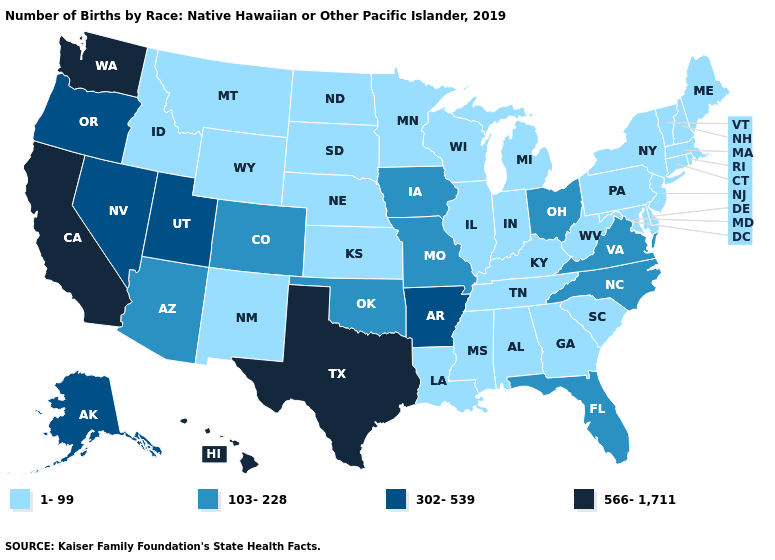Which states have the lowest value in the West?
Be succinct. Idaho, Montana, New Mexico, Wyoming. Name the states that have a value in the range 302-539?
Answer briefly. Alaska, Arkansas, Nevada, Oregon, Utah. What is the highest value in the USA?
Be succinct. 566-1,711. Among the states that border Indiana , does Illinois have the lowest value?
Answer briefly. Yes. Name the states that have a value in the range 1-99?
Write a very short answer. Alabama, Connecticut, Delaware, Georgia, Idaho, Illinois, Indiana, Kansas, Kentucky, Louisiana, Maine, Maryland, Massachusetts, Michigan, Minnesota, Mississippi, Montana, Nebraska, New Hampshire, New Jersey, New Mexico, New York, North Dakota, Pennsylvania, Rhode Island, South Carolina, South Dakota, Tennessee, Vermont, West Virginia, Wisconsin, Wyoming. What is the value of Tennessee?
Answer briefly. 1-99. What is the value of Tennessee?
Quick response, please. 1-99. Does Ohio have the highest value in the MidWest?
Quick response, please. Yes. What is the value of Montana?
Keep it brief. 1-99. Does Montana have the lowest value in the West?
Short answer required. Yes. Among the states that border Indiana , which have the highest value?
Give a very brief answer. Ohio. What is the highest value in the South ?
Be succinct. 566-1,711. Among the states that border Wyoming , which have the lowest value?
Write a very short answer. Idaho, Montana, Nebraska, South Dakota. Name the states that have a value in the range 103-228?
Answer briefly. Arizona, Colorado, Florida, Iowa, Missouri, North Carolina, Ohio, Oklahoma, Virginia. 